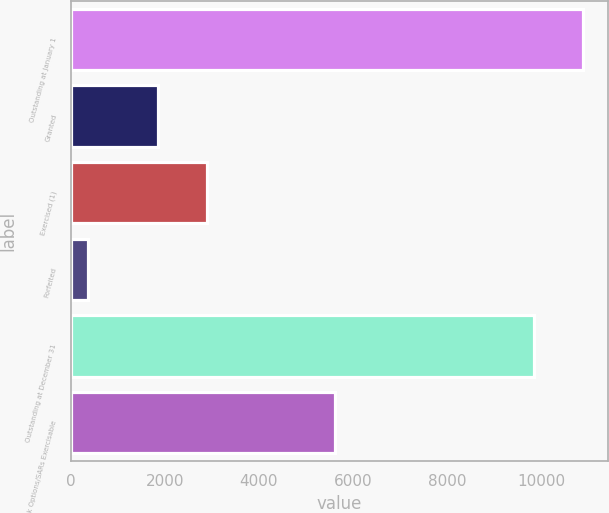Convert chart to OTSL. <chart><loc_0><loc_0><loc_500><loc_500><bar_chart><fcel>Outstanding at January 1<fcel>Granted<fcel>Exercised (1)<fcel>Forfeited<fcel>Outstanding at December 31<fcel>Stock Options/SARs Exercisable<nl><fcel>10887.1<fcel>1855<fcel>2892.1<fcel>373<fcel>9850<fcel>5613<nl></chart> 